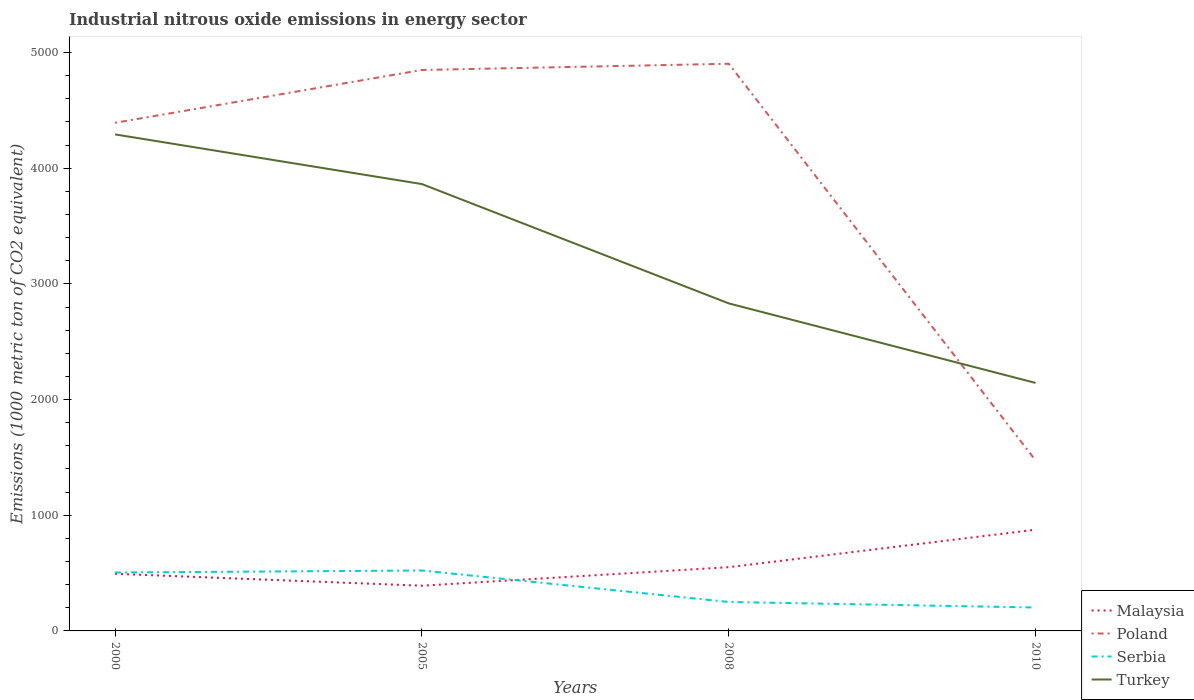Across all years, what is the maximum amount of industrial nitrous oxide emitted in Poland?
Provide a short and direct response. 1474.1. In which year was the amount of industrial nitrous oxide emitted in Turkey maximum?
Make the answer very short. 2010. What is the total amount of industrial nitrous oxide emitted in Poland in the graph?
Your answer should be very brief. -456.5. What is the difference between the highest and the second highest amount of industrial nitrous oxide emitted in Poland?
Give a very brief answer. 3428.6. How many lines are there?
Offer a terse response. 4. How many years are there in the graph?
Make the answer very short. 4. Does the graph contain grids?
Offer a terse response. No. What is the title of the graph?
Offer a terse response. Industrial nitrous oxide emissions in energy sector. Does "Tonga" appear as one of the legend labels in the graph?
Offer a terse response. No. What is the label or title of the Y-axis?
Keep it short and to the point. Emissions (1000 metric ton of CO2 equivalent). What is the Emissions (1000 metric ton of CO2 equivalent) in Malaysia in 2000?
Keep it short and to the point. 493.8. What is the Emissions (1000 metric ton of CO2 equivalent) of Poland in 2000?
Your response must be concise. 4392.5. What is the Emissions (1000 metric ton of CO2 equivalent) in Serbia in 2000?
Your answer should be very brief. 505. What is the Emissions (1000 metric ton of CO2 equivalent) of Turkey in 2000?
Provide a succinct answer. 4292. What is the Emissions (1000 metric ton of CO2 equivalent) in Malaysia in 2005?
Provide a succinct answer. 390.9. What is the Emissions (1000 metric ton of CO2 equivalent) of Poland in 2005?
Give a very brief answer. 4849. What is the Emissions (1000 metric ton of CO2 equivalent) in Serbia in 2005?
Your response must be concise. 522.3. What is the Emissions (1000 metric ton of CO2 equivalent) of Turkey in 2005?
Give a very brief answer. 3862.7. What is the Emissions (1000 metric ton of CO2 equivalent) in Malaysia in 2008?
Make the answer very short. 551. What is the Emissions (1000 metric ton of CO2 equivalent) of Poland in 2008?
Keep it short and to the point. 4902.7. What is the Emissions (1000 metric ton of CO2 equivalent) of Serbia in 2008?
Ensure brevity in your answer.  250.3. What is the Emissions (1000 metric ton of CO2 equivalent) of Turkey in 2008?
Make the answer very short. 2831.3. What is the Emissions (1000 metric ton of CO2 equivalent) in Malaysia in 2010?
Keep it short and to the point. 874.9. What is the Emissions (1000 metric ton of CO2 equivalent) in Poland in 2010?
Your answer should be very brief. 1474.1. What is the Emissions (1000 metric ton of CO2 equivalent) in Serbia in 2010?
Offer a terse response. 202.3. What is the Emissions (1000 metric ton of CO2 equivalent) in Turkey in 2010?
Your answer should be compact. 2143.8. Across all years, what is the maximum Emissions (1000 metric ton of CO2 equivalent) in Malaysia?
Give a very brief answer. 874.9. Across all years, what is the maximum Emissions (1000 metric ton of CO2 equivalent) in Poland?
Offer a very short reply. 4902.7. Across all years, what is the maximum Emissions (1000 metric ton of CO2 equivalent) of Serbia?
Give a very brief answer. 522.3. Across all years, what is the maximum Emissions (1000 metric ton of CO2 equivalent) in Turkey?
Offer a terse response. 4292. Across all years, what is the minimum Emissions (1000 metric ton of CO2 equivalent) of Malaysia?
Make the answer very short. 390.9. Across all years, what is the minimum Emissions (1000 metric ton of CO2 equivalent) in Poland?
Ensure brevity in your answer.  1474.1. Across all years, what is the minimum Emissions (1000 metric ton of CO2 equivalent) in Serbia?
Offer a terse response. 202.3. Across all years, what is the minimum Emissions (1000 metric ton of CO2 equivalent) of Turkey?
Make the answer very short. 2143.8. What is the total Emissions (1000 metric ton of CO2 equivalent) in Malaysia in the graph?
Your response must be concise. 2310.6. What is the total Emissions (1000 metric ton of CO2 equivalent) of Poland in the graph?
Provide a short and direct response. 1.56e+04. What is the total Emissions (1000 metric ton of CO2 equivalent) of Serbia in the graph?
Give a very brief answer. 1479.9. What is the total Emissions (1000 metric ton of CO2 equivalent) in Turkey in the graph?
Your response must be concise. 1.31e+04. What is the difference between the Emissions (1000 metric ton of CO2 equivalent) of Malaysia in 2000 and that in 2005?
Keep it short and to the point. 102.9. What is the difference between the Emissions (1000 metric ton of CO2 equivalent) in Poland in 2000 and that in 2005?
Your response must be concise. -456.5. What is the difference between the Emissions (1000 metric ton of CO2 equivalent) of Serbia in 2000 and that in 2005?
Give a very brief answer. -17.3. What is the difference between the Emissions (1000 metric ton of CO2 equivalent) in Turkey in 2000 and that in 2005?
Offer a very short reply. 429.3. What is the difference between the Emissions (1000 metric ton of CO2 equivalent) in Malaysia in 2000 and that in 2008?
Your response must be concise. -57.2. What is the difference between the Emissions (1000 metric ton of CO2 equivalent) of Poland in 2000 and that in 2008?
Offer a terse response. -510.2. What is the difference between the Emissions (1000 metric ton of CO2 equivalent) in Serbia in 2000 and that in 2008?
Give a very brief answer. 254.7. What is the difference between the Emissions (1000 metric ton of CO2 equivalent) in Turkey in 2000 and that in 2008?
Give a very brief answer. 1460.7. What is the difference between the Emissions (1000 metric ton of CO2 equivalent) of Malaysia in 2000 and that in 2010?
Provide a succinct answer. -381.1. What is the difference between the Emissions (1000 metric ton of CO2 equivalent) in Poland in 2000 and that in 2010?
Provide a succinct answer. 2918.4. What is the difference between the Emissions (1000 metric ton of CO2 equivalent) in Serbia in 2000 and that in 2010?
Offer a very short reply. 302.7. What is the difference between the Emissions (1000 metric ton of CO2 equivalent) of Turkey in 2000 and that in 2010?
Ensure brevity in your answer.  2148.2. What is the difference between the Emissions (1000 metric ton of CO2 equivalent) of Malaysia in 2005 and that in 2008?
Offer a very short reply. -160.1. What is the difference between the Emissions (1000 metric ton of CO2 equivalent) of Poland in 2005 and that in 2008?
Provide a succinct answer. -53.7. What is the difference between the Emissions (1000 metric ton of CO2 equivalent) of Serbia in 2005 and that in 2008?
Your response must be concise. 272. What is the difference between the Emissions (1000 metric ton of CO2 equivalent) in Turkey in 2005 and that in 2008?
Provide a short and direct response. 1031.4. What is the difference between the Emissions (1000 metric ton of CO2 equivalent) in Malaysia in 2005 and that in 2010?
Your answer should be very brief. -484. What is the difference between the Emissions (1000 metric ton of CO2 equivalent) of Poland in 2005 and that in 2010?
Your answer should be very brief. 3374.9. What is the difference between the Emissions (1000 metric ton of CO2 equivalent) of Serbia in 2005 and that in 2010?
Make the answer very short. 320. What is the difference between the Emissions (1000 metric ton of CO2 equivalent) in Turkey in 2005 and that in 2010?
Ensure brevity in your answer.  1718.9. What is the difference between the Emissions (1000 metric ton of CO2 equivalent) in Malaysia in 2008 and that in 2010?
Your answer should be very brief. -323.9. What is the difference between the Emissions (1000 metric ton of CO2 equivalent) of Poland in 2008 and that in 2010?
Provide a short and direct response. 3428.6. What is the difference between the Emissions (1000 metric ton of CO2 equivalent) of Serbia in 2008 and that in 2010?
Keep it short and to the point. 48. What is the difference between the Emissions (1000 metric ton of CO2 equivalent) in Turkey in 2008 and that in 2010?
Give a very brief answer. 687.5. What is the difference between the Emissions (1000 metric ton of CO2 equivalent) of Malaysia in 2000 and the Emissions (1000 metric ton of CO2 equivalent) of Poland in 2005?
Your response must be concise. -4355.2. What is the difference between the Emissions (1000 metric ton of CO2 equivalent) in Malaysia in 2000 and the Emissions (1000 metric ton of CO2 equivalent) in Serbia in 2005?
Ensure brevity in your answer.  -28.5. What is the difference between the Emissions (1000 metric ton of CO2 equivalent) of Malaysia in 2000 and the Emissions (1000 metric ton of CO2 equivalent) of Turkey in 2005?
Offer a terse response. -3368.9. What is the difference between the Emissions (1000 metric ton of CO2 equivalent) in Poland in 2000 and the Emissions (1000 metric ton of CO2 equivalent) in Serbia in 2005?
Provide a succinct answer. 3870.2. What is the difference between the Emissions (1000 metric ton of CO2 equivalent) of Poland in 2000 and the Emissions (1000 metric ton of CO2 equivalent) of Turkey in 2005?
Offer a terse response. 529.8. What is the difference between the Emissions (1000 metric ton of CO2 equivalent) in Serbia in 2000 and the Emissions (1000 metric ton of CO2 equivalent) in Turkey in 2005?
Give a very brief answer. -3357.7. What is the difference between the Emissions (1000 metric ton of CO2 equivalent) of Malaysia in 2000 and the Emissions (1000 metric ton of CO2 equivalent) of Poland in 2008?
Give a very brief answer. -4408.9. What is the difference between the Emissions (1000 metric ton of CO2 equivalent) of Malaysia in 2000 and the Emissions (1000 metric ton of CO2 equivalent) of Serbia in 2008?
Your response must be concise. 243.5. What is the difference between the Emissions (1000 metric ton of CO2 equivalent) in Malaysia in 2000 and the Emissions (1000 metric ton of CO2 equivalent) in Turkey in 2008?
Your answer should be compact. -2337.5. What is the difference between the Emissions (1000 metric ton of CO2 equivalent) in Poland in 2000 and the Emissions (1000 metric ton of CO2 equivalent) in Serbia in 2008?
Offer a very short reply. 4142.2. What is the difference between the Emissions (1000 metric ton of CO2 equivalent) in Poland in 2000 and the Emissions (1000 metric ton of CO2 equivalent) in Turkey in 2008?
Keep it short and to the point. 1561.2. What is the difference between the Emissions (1000 metric ton of CO2 equivalent) of Serbia in 2000 and the Emissions (1000 metric ton of CO2 equivalent) of Turkey in 2008?
Keep it short and to the point. -2326.3. What is the difference between the Emissions (1000 metric ton of CO2 equivalent) of Malaysia in 2000 and the Emissions (1000 metric ton of CO2 equivalent) of Poland in 2010?
Make the answer very short. -980.3. What is the difference between the Emissions (1000 metric ton of CO2 equivalent) in Malaysia in 2000 and the Emissions (1000 metric ton of CO2 equivalent) in Serbia in 2010?
Your answer should be very brief. 291.5. What is the difference between the Emissions (1000 metric ton of CO2 equivalent) in Malaysia in 2000 and the Emissions (1000 metric ton of CO2 equivalent) in Turkey in 2010?
Keep it short and to the point. -1650. What is the difference between the Emissions (1000 metric ton of CO2 equivalent) of Poland in 2000 and the Emissions (1000 metric ton of CO2 equivalent) of Serbia in 2010?
Keep it short and to the point. 4190.2. What is the difference between the Emissions (1000 metric ton of CO2 equivalent) of Poland in 2000 and the Emissions (1000 metric ton of CO2 equivalent) of Turkey in 2010?
Offer a terse response. 2248.7. What is the difference between the Emissions (1000 metric ton of CO2 equivalent) of Serbia in 2000 and the Emissions (1000 metric ton of CO2 equivalent) of Turkey in 2010?
Provide a succinct answer. -1638.8. What is the difference between the Emissions (1000 metric ton of CO2 equivalent) of Malaysia in 2005 and the Emissions (1000 metric ton of CO2 equivalent) of Poland in 2008?
Make the answer very short. -4511.8. What is the difference between the Emissions (1000 metric ton of CO2 equivalent) of Malaysia in 2005 and the Emissions (1000 metric ton of CO2 equivalent) of Serbia in 2008?
Keep it short and to the point. 140.6. What is the difference between the Emissions (1000 metric ton of CO2 equivalent) of Malaysia in 2005 and the Emissions (1000 metric ton of CO2 equivalent) of Turkey in 2008?
Provide a short and direct response. -2440.4. What is the difference between the Emissions (1000 metric ton of CO2 equivalent) in Poland in 2005 and the Emissions (1000 metric ton of CO2 equivalent) in Serbia in 2008?
Keep it short and to the point. 4598.7. What is the difference between the Emissions (1000 metric ton of CO2 equivalent) in Poland in 2005 and the Emissions (1000 metric ton of CO2 equivalent) in Turkey in 2008?
Provide a short and direct response. 2017.7. What is the difference between the Emissions (1000 metric ton of CO2 equivalent) of Serbia in 2005 and the Emissions (1000 metric ton of CO2 equivalent) of Turkey in 2008?
Ensure brevity in your answer.  -2309. What is the difference between the Emissions (1000 metric ton of CO2 equivalent) in Malaysia in 2005 and the Emissions (1000 metric ton of CO2 equivalent) in Poland in 2010?
Provide a succinct answer. -1083.2. What is the difference between the Emissions (1000 metric ton of CO2 equivalent) of Malaysia in 2005 and the Emissions (1000 metric ton of CO2 equivalent) of Serbia in 2010?
Provide a succinct answer. 188.6. What is the difference between the Emissions (1000 metric ton of CO2 equivalent) in Malaysia in 2005 and the Emissions (1000 metric ton of CO2 equivalent) in Turkey in 2010?
Make the answer very short. -1752.9. What is the difference between the Emissions (1000 metric ton of CO2 equivalent) in Poland in 2005 and the Emissions (1000 metric ton of CO2 equivalent) in Serbia in 2010?
Your answer should be compact. 4646.7. What is the difference between the Emissions (1000 metric ton of CO2 equivalent) in Poland in 2005 and the Emissions (1000 metric ton of CO2 equivalent) in Turkey in 2010?
Provide a succinct answer. 2705.2. What is the difference between the Emissions (1000 metric ton of CO2 equivalent) of Serbia in 2005 and the Emissions (1000 metric ton of CO2 equivalent) of Turkey in 2010?
Ensure brevity in your answer.  -1621.5. What is the difference between the Emissions (1000 metric ton of CO2 equivalent) of Malaysia in 2008 and the Emissions (1000 metric ton of CO2 equivalent) of Poland in 2010?
Provide a succinct answer. -923.1. What is the difference between the Emissions (1000 metric ton of CO2 equivalent) of Malaysia in 2008 and the Emissions (1000 metric ton of CO2 equivalent) of Serbia in 2010?
Make the answer very short. 348.7. What is the difference between the Emissions (1000 metric ton of CO2 equivalent) in Malaysia in 2008 and the Emissions (1000 metric ton of CO2 equivalent) in Turkey in 2010?
Offer a terse response. -1592.8. What is the difference between the Emissions (1000 metric ton of CO2 equivalent) of Poland in 2008 and the Emissions (1000 metric ton of CO2 equivalent) of Serbia in 2010?
Ensure brevity in your answer.  4700.4. What is the difference between the Emissions (1000 metric ton of CO2 equivalent) in Poland in 2008 and the Emissions (1000 metric ton of CO2 equivalent) in Turkey in 2010?
Your response must be concise. 2758.9. What is the difference between the Emissions (1000 metric ton of CO2 equivalent) of Serbia in 2008 and the Emissions (1000 metric ton of CO2 equivalent) of Turkey in 2010?
Provide a succinct answer. -1893.5. What is the average Emissions (1000 metric ton of CO2 equivalent) in Malaysia per year?
Offer a terse response. 577.65. What is the average Emissions (1000 metric ton of CO2 equivalent) of Poland per year?
Your answer should be very brief. 3904.57. What is the average Emissions (1000 metric ton of CO2 equivalent) of Serbia per year?
Keep it short and to the point. 369.98. What is the average Emissions (1000 metric ton of CO2 equivalent) in Turkey per year?
Your response must be concise. 3282.45. In the year 2000, what is the difference between the Emissions (1000 metric ton of CO2 equivalent) of Malaysia and Emissions (1000 metric ton of CO2 equivalent) of Poland?
Your response must be concise. -3898.7. In the year 2000, what is the difference between the Emissions (1000 metric ton of CO2 equivalent) in Malaysia and Emissions (1000 metric ton of CO2 equivalent) in Turkey?
Make the answer very short. -3798.2. In the year 2000, what is the difference between the Emissions (1000 metric ton of CO2 equivalent) in Poland and Emissions (1000 metric ton of CO2 equivalent) in Serbia?
Offer a terse response. 3887.5. In the year 2000, what is the difference between the Emissions (1000 metric ton of CO2 equivalent) in Poland and Emissions (1000 metric ton of CO2 equivalent) in Turkey?
Provide a short and direct response. 100.5. In the year 2000, what is the difference between the Emissions (1000 metric ton of CO2 equivalent) of Serbia and Emissions (1000 metric ton of CO2 equivalent) of Turkey?
Your response must be concise. -3787. In the year 2005, what is the difference between the Emissions (1000 metric ton of CO2 equivalent) in Malaysia and Emissions (1000 metric ton of CO2 equivalent) in Poland?
Your response must be concise. -4458.1. In the year 2005, what is the difference between the Emissions (1000 metric ton of CO2 equivalent) of Malaysia and Emissions (1000 metric ton of CO2 equivalent) of Serbia?
Provide a succinct answer. -131.4. In the year 2005, what is the difference between the Emissions (1000 metric ton of CO2 equivalent) in Malaysia and Emissions (1000 metric ton of CO2 equivalent) in Turkey?
Your answer should be very brief. -3471.8. In the year 2005, what is the difference between the Emissions (1000 metric ton of CO2 equivalent) of Poland and Emissions (1000 metric ton of CO2 equivalent) of Serbia?
Your response must be concise. 4326.7. In the year 2005, what is the difference between the Emissions (1000 metric ton of CO2 equivalent) in Poland and Emissions (1000 metric ton of CO2 equivalent) in Turkey?
Ensure brevity in your answer.  986.3. In the year 2005, what is the difference between the Emissions (1000 metric ton of CO2 equivalent) in Serbia and Emissions (1000 metric ton of CO2 equivalent) in Turkey?
Your answer should be very brief. -3340.4. In the year 2008, what is the difference between the Emissions (1000 metric ton of CO2 equivalent) of Malaysia and Emissions (1000 metric ton of CO2 equivalent) of Poland?
Ensure brevity in your answer.  -4351.7. In the year 2008, what is the difference between the Emissions (1000 metric ton of CO2 equivalent) in Malaysia and Emissions (1000 metric ton of CO2 equivalent) in Serbia?
Make the answer very short. 300.7. In the year 2008, what is the difference between the Emissions (1000 metric ton of CO2 equivalent) in Malaysia and Emissions (1000 metric ton of CO2 equivalent) in Turkey?
Provide a short and direct response. -2280.3. In the year 2008, what is the difference between the Emissions (1000 metric ton of CO2 equivalent) of Poland and Emissions (1000 metric ton of CO2 equivalent) of Serbia?
Give a very brief answer. 4652.4. In the year 2008, what is the difference between the Emissions (1000 metric ton of CO2 equivalent) in Poland and Emissions (1000 metric ton of CO2 equivalent) in Turkey?
Keep it short and to the point. 2071.4. In the year 2008, what is the difference between the Emissions (1000 metric ton of CO2 equivalent) in Serbia and Emissions (1000 metric ton of CO2 equivalent) in Turkey?
Offer a very short reply. -2581. In the year 2010, what is the difference between the Emissions (1000 metric ton of CO2 equivalent) of Malaysia and Emissions (1000 metric ton of CO2 equivalent) of Poland?
Provide a short and direct response. -599.2. In the year 2010, what is the difference between the Emissions (1000 metric ton of CO2 equivalent) of Malaysia and Emissions (1000 metric ton of CO2 equivalent) of Serbia?
Your response must be concise. 672.6. In the year 2010, what is the difference between the Emissions (1000 metric ton of CO2 equivalent) in Malaysia and Emissions (1000 metric ton of CO2 equivalent) in Turkey?
Your response must be concise. -1268.9. In the year 2010, what is the difference between the Emissions (1000 metric ton of CO2 equivalent) in Poland and Emissions (1000 metric ton of CO2 equivalent) in Serbia?
Keep it short and to the point. 1271.8. In the year 2010, what is the difference between the Emissions (1000 metric ton of CO2 equivalent) of Poland and Emissions (1000 metric ton of CO2 equivalent) of Turkey?
Keep it short and to the point. -669.7. In the year 2010, what is the difference between the Emissions (1000 metric ton of CO2 equivalent) of Serbia and Emissions (1000 metric ton of CO2 equivalent) of Turkey?
Give a very brief answer. -1941.5. What is the ratio of the Emissions (1000 metric ton of CO2 equivalent) in Malaysia in 2000 to that in 2005?
Your answer should be very brief. 1.26. What is the ratio of the Emissions (1000 metric ton of CO2 equivalent) in Poland in 2000 to that in 2005?
Provide a short and direct response. 0.91. What is the ratio of the Emissions (1000 metric ton of CO2 equivalent) in Serbia in 2000 to that in 2005?
Your answer should be compact. 0.97. What is the ratio of the Emissions (1000 metric ton of CO2 equivalent) of Turkey in 2000 to that in 2005?
Ensure brevity in your answer.  1.11. What is the ratio of the Emissions (1000 metric ton of CO2 equivalent) of Malaysia in 2000 to that in 2008?
Offer a very short reply. 0.9. What is the ratio of the Emissions (1000 metric ton of CO2 equivalent) in Poland in 2000 to that in 2008?
Your answer should be compact. 0.9. What is the ratio of the Emissions (1000 metric ton of CO2 equivalent) of Serbia in 2000 to that in 2008?
Provide a short and direct response. 2.02. What is the ratio of the Emissions (1000 metric ton of CO2 equivalent) in Turkey in 2000 to that in 2008?
Offer a terse response. 1.52. What is the ratio of the Emissions (1000 metric ton of CO2 equivalent) of Malaysia in 2000 to that in 2010?
Ensure brevity in your answer.  0.56. What is the ratio of the Emissions (1000 metric ton of CO2 equivalent) in Poland in 2000 to that in 2010?
Keep it short and to the point. 2.98. What is the ratio of the Emissions (1000 metric ton of CO2 equivalent) of Serbia in 2000 to that in 2010?
Your answer should be very brief. 2.5. What is the ratio of the Emissions (1000 metric ton of CO2 equivalent) of Turkey in 2000 to that in 2010?
Provide a short and direct response. 2. What is the ratio of the Emissions (1000 metric ton of CO2 equivalent) in Malaysia in 2005 to that in 2008?
Offer a terse response. 0.71. What is the ratio of the Emissions (1000 metric ton of CO2 equivalent) in Poland in 2005 to that in 2008?
Your answer should be compact. 0.99. What is the ratio of the Emissions (1000 metric ton of CO2 equivalent) in Serbia in 2005 to that in 2008?
Give a very brief answer. 2.09. What is the ratio of the Emissions (1000 metric ton of CO2 equivalent) of Turkey in 2005 to that in 2008?
Keep it short and to the point. 1.36. What is the ratio of the Emissions (1000 metric ton of CO2 equivalent) in Malaysia in 2005 to that in 2010?
Your response must be concise. 0.45. What is the ratio of the Emissions (1000 metric ton of CO2 equivalent) of Poland in 2005 to that in 2010?
Ensure brevity in your answer.  3.29. What is the ratio of the Emissions (1000 metric ton of CO2 equivalent) of Serbia in 2005 to that in 2010?
Ensure brevity in your answer.  2.58. What is the ratio of the Emissions (1000 metric ton of CO2 equivalent) in Turkey in 2005 to that in 2010?
Keep it short and to the point. 1.8. What is the ratio of the Emissions (1000 metric ton of CO2 equivalent) in Malaysia in 2008 to that in 2010?
Keep it short and to the point. 0.63. What is the ratio of the Emissions (1000 metric ton of CO2 equivalent) of Poland in 2008 to that in 2010?
Ensure brevity in your answer.  3.33. What is the ratio of the Emissions (1000 metric ton of CO2 equivalent) in Serbia in 2008 to that in 2010?
Keep it short and to the point. 1.24. What is the ratio of the Emissions (1000 metric ton of CO2 equivalent) in Turkey in 2008 to that in 2010?
Your response must be concise. 1.32. What is the difference between the highest and the second highest Emissions (1000 metric ton of CO2 equivalent) of Malaysia?
Offer a terse response. 323.9. What is the difference between the highest and the second highest Emissions (1000 metric ton of CO2 equivalent) in Poland?
Your answer should be compact. 53.7. What is the difference between the highest and the second highest Emissions (1000 metric ton of CO2 equivalent) in Turkey?
Offer a terse response. 429.3. What is the difference between the highest and the lowest Emissions (1000 metric ton of CO2 equivalent) in Malaysia?
Your answer should be very brief. 484. What is the difference between the highest and the lowest Emissions (1000 metric ton of CO2 equivalent) in Poland?
Provide a short and direct response. 3428.6. What is the difference between the highest and the lowest Emissions (1000 metric ton of CO2 equivalent) in Serbia?
Give a very brief answer. 320. What is the difference between the highest and the lowest Emissions (1000 metric ton of CO2 equivalent) in Turkey?
Offer a very short reply. 2148.2. 